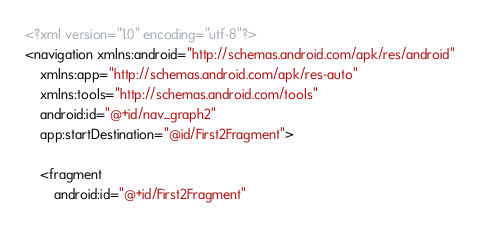Convert code to text. <code><loc_0><loc_0><loc_500><loc_500><_XML_><?xml version="1.0" encoding="utf-8"?>
<navigation xmlns:android="http://schemas.android.com/apk/res/android"
    xmlns:app="http://schemas.android.com/apk/res-auto"
    xmlns:tools="http://schemas.android.com/tools"
    android:id="@+id/nav_graph2"
    app:startDestination="@id/First2Fragment">

    <fragment
        android:id="@+id/First2Fragment"</code> 